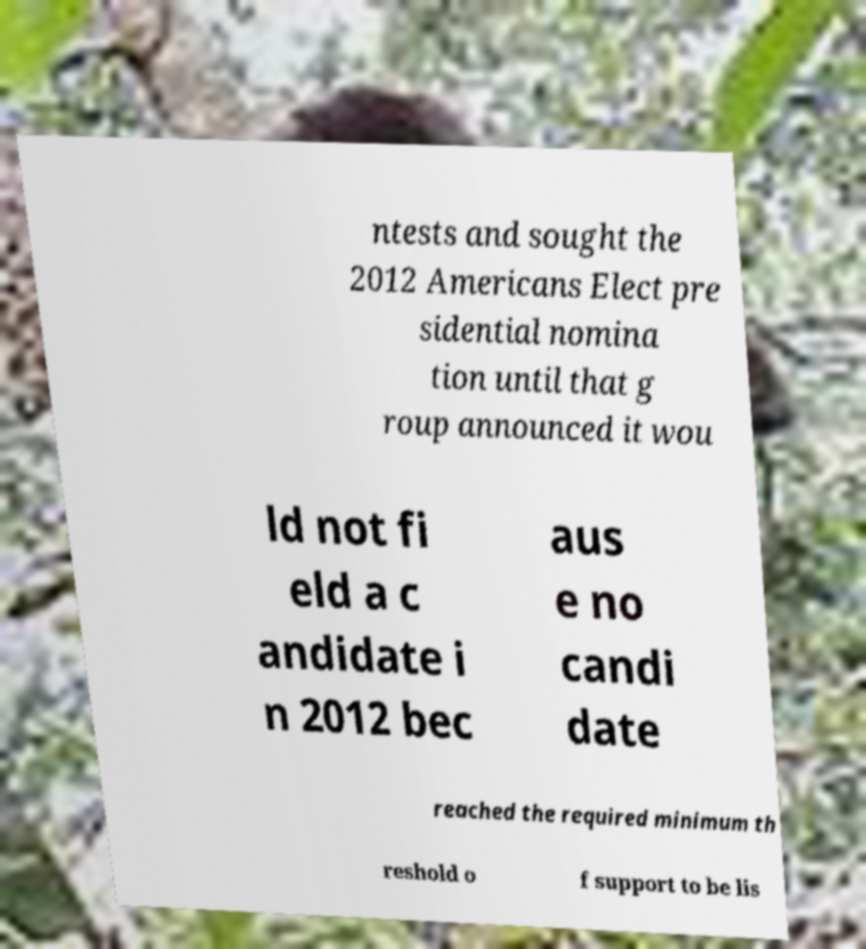Please read and relay the text visible in this image. What does it say? ntests and sought the 2012 Americans Elect pre sidential nomina tion until that g roup announced it wou ld not fi eld a c andidate i n 2012 bec aus e no candi date reached the required minimum th reshold o f support to be lis 